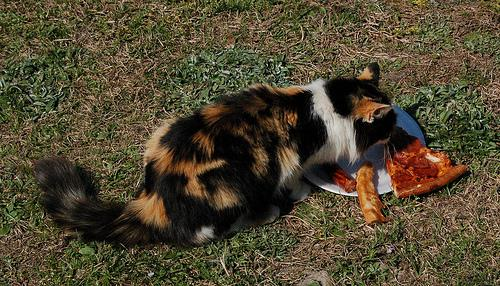Question: where was the picture taken?
Choices:
A. In the boat.
B. At the zoo.
C. Yard.
D. On the couch.
Answer with the letter. Answer: C Question: when was the picture taken?
Choices:
A. Night time.
B. Afternoon.
C. Early morning.
D. Late evening.
Answer with the letter. Answer: B Question: what kind of cat is pictured?
Choices:
A. White.
B. Brown.
C. Calico.
D. Tan.
Answer with the letter. Answer: C Question: why is the cat eating pizza?
Choices:
A. He is naughty.
B. He doesn't know when he will eat again.
C. It is what was put out for him to eat.
D. Hungry.
Answer with the letter. Answer: D Question: who is holding the cat?
Choices:
A. Grandma.
B. Nobody.
C. It's Mother.
D. Dad.
Answer with the letter. Answer: B 